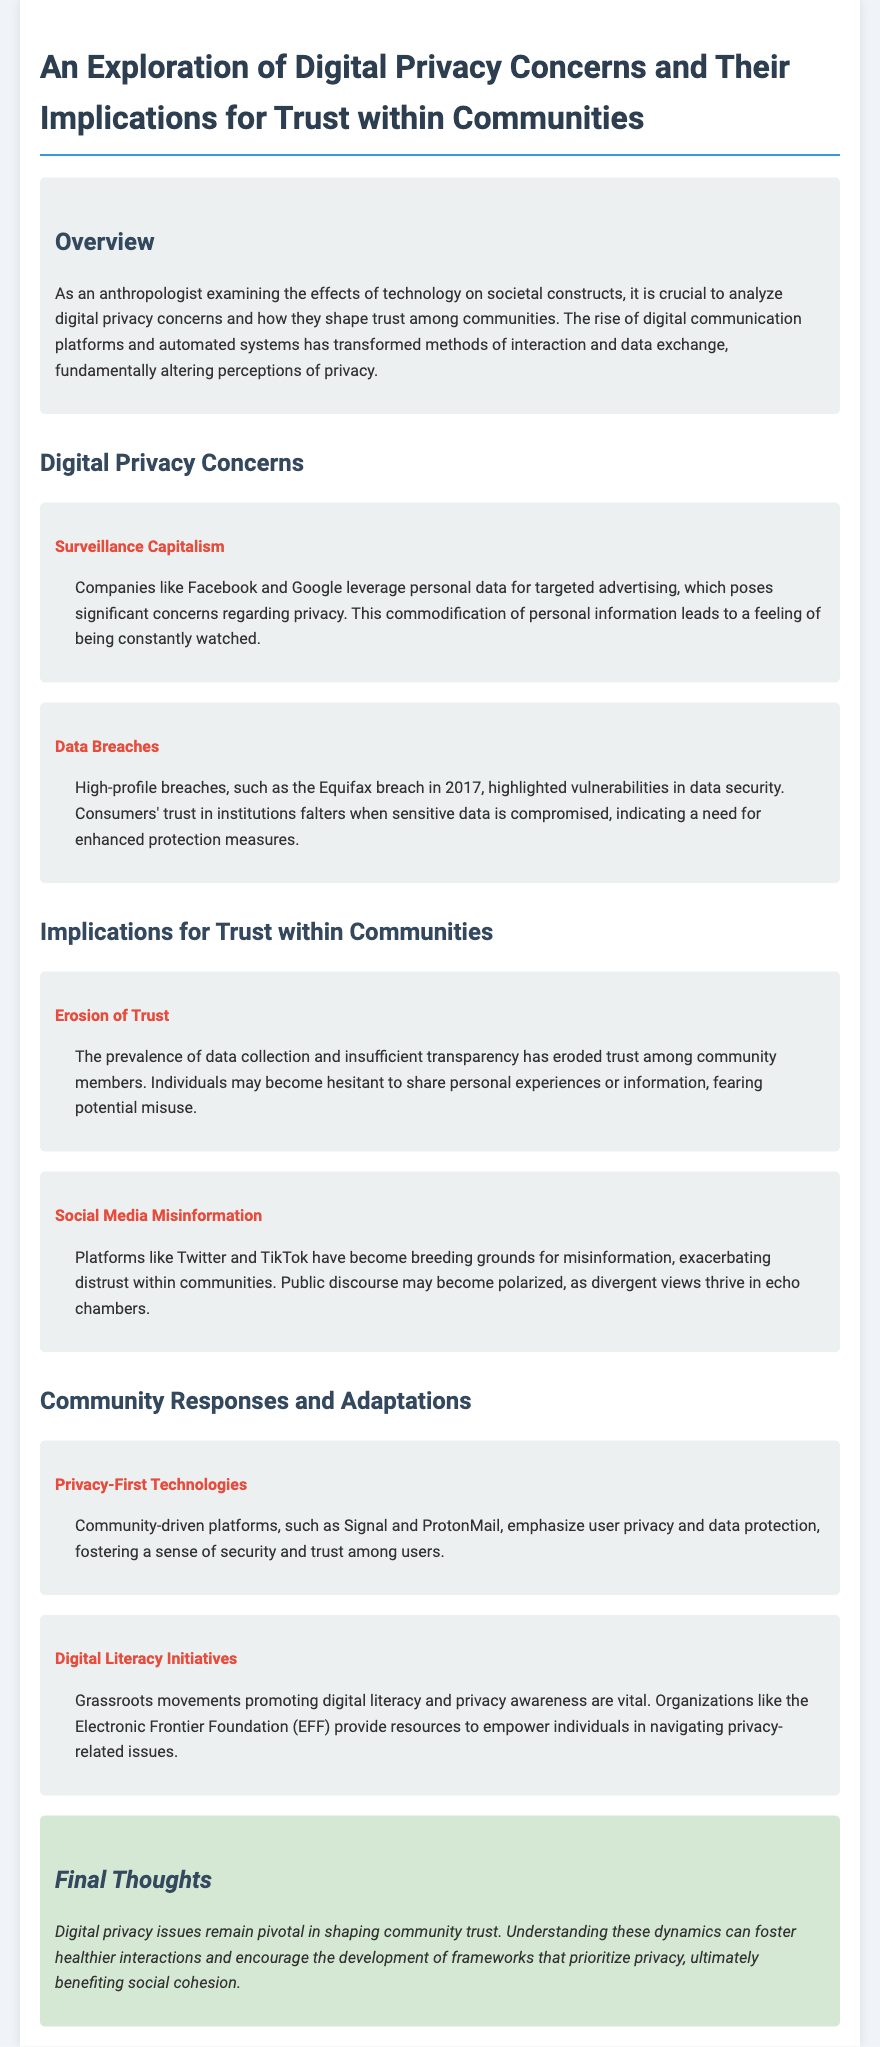What is the title of the document? The title of the document is provided in the `<title>` tag of the HTML code, which states the main topic being explored.
Answer: An Exploration of Digital Privacy Concerns and Their Implications for Trust within Communities How many high-profile data breaches are mentioned? The note refers specifically to one major incident to illustrate vulnerabilities in data security.
Answer: One What technology platforms emphasize user privacy? The document provides examples of community-driven platforms that focus on privacy and data protection.
Answer: Signal and ProtonMail What organization is mentioned for promoting digital literacy? The organization mentioned in the text that provides resources for privacy awareness is a known advocate for digital rights.
Answer: Electronic Frontier Foundation What effect does data collection have on community trust? The document discusses the relationship between data collection practices and trust within communities, specifically noting a direct impact.
Answer: Eroded trust Which phenomenon exacerbates distrust within communities according to the document? This aspect is discussed in relation to social media platforms and the sharing of false information.
Answer: Social Media Misinformation What year did the Equifax data breach occur? The document cites the year of a significant data security incident that serves as an example of vulnerabilities in data security.
Answer: 2017 